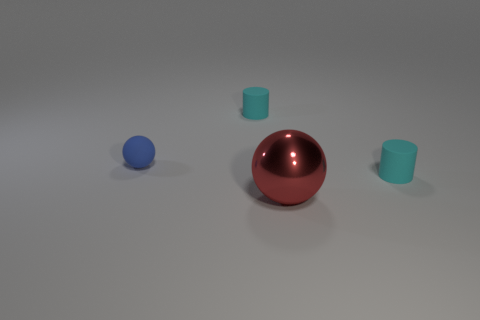Add 1 big red metal balls. How many objects exist? 5 Subtract all red balls. How many balls are left? 1 Add 2 big blue spheres. How many big blue spheres exist? 2 Subtract 0 green spheres. How many objects are left? 4 Subtract all green cylinders. Subtract all gray cubes. How many cylinders are left? 2 Subtract all tiny balls. Subtract all large yellow matte cylinders. How many objects are left? 3 Add 3 blue rubber objects. How many blue rubber objects are left? 4 